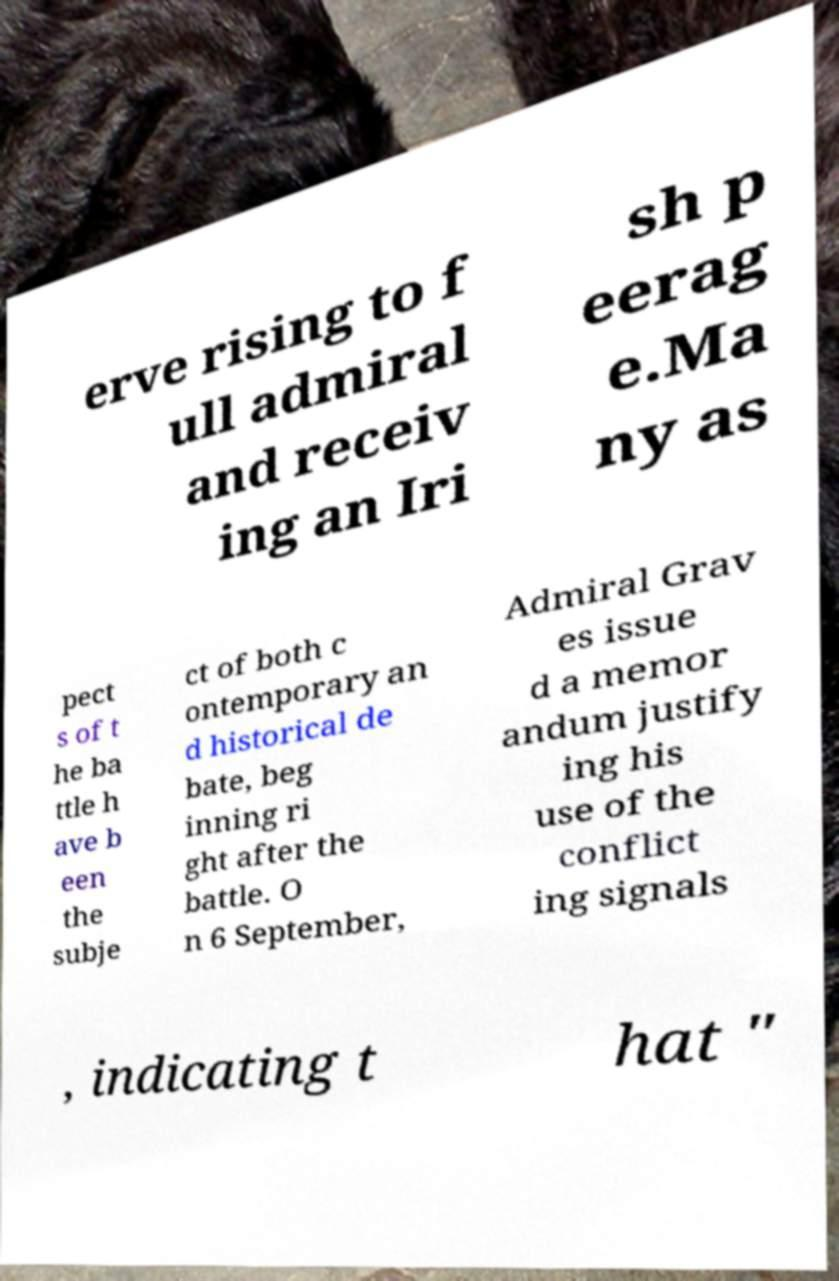Can you read and provide the text displayed in the image?This photo seems to have some interesting text. Can you extract and type it out for me? erve rising to f ull admiral and receiv ing an Iri sh p eerag e.Ma ny as pect s of t he ba ttle h ave b een the subje ct of both c ontemporary an d historical de bate, beg inning ri ght after the battle. O n 6 September, Admiral Grav es issue d a memor andum justify ing his use of the conflict ing signals , indicating t hat " 